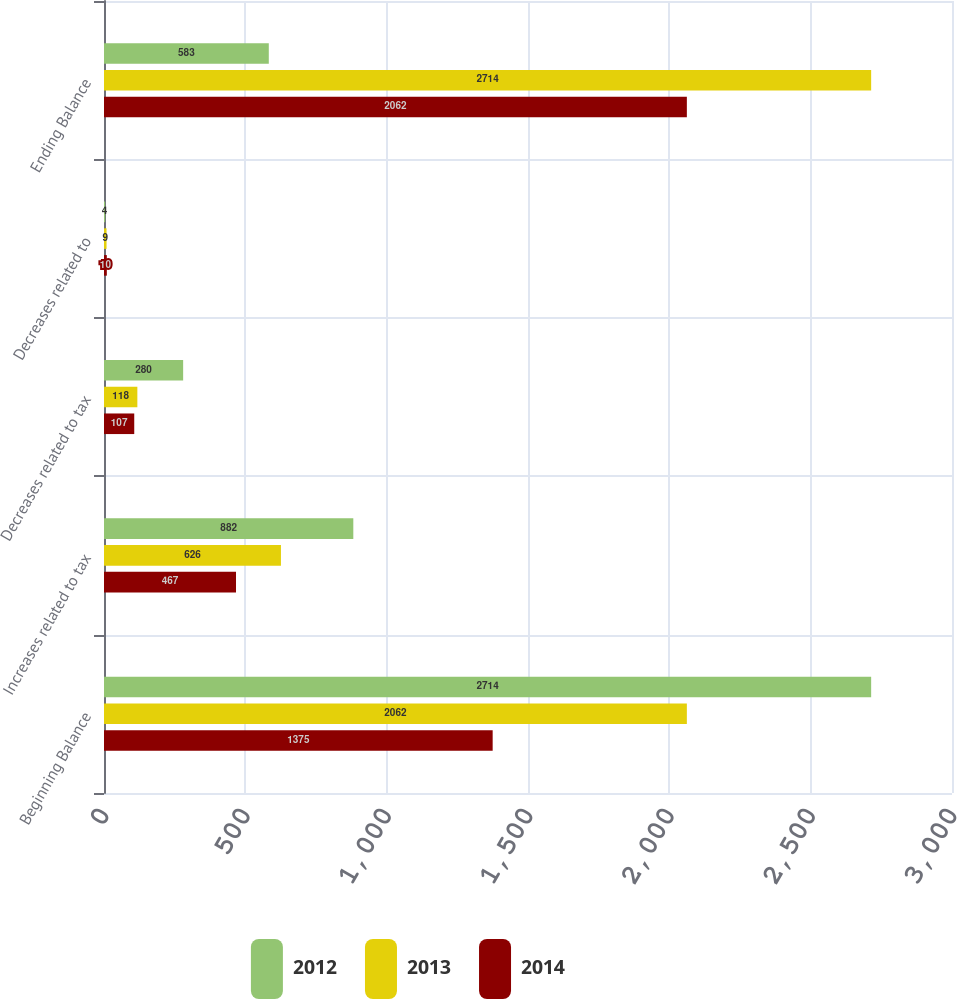Convert chart to OTSL. <chart><loc_0><loc_0><loc_500><loc_500><stacked_bar_chart><ecel><fcel>Beginning Balance<fcel>Increases related to tax<fcel>Decreases related to tax<fcel>Decreases related to<fcel>Ending Balance<nl><fcel>2012<fcel>2714<fcel>882<fcel>280<fcel>4<fcel>583<nl><fcel>2013<fcel>2062<fcel>626<fcel>118<fcel>9<fcel>2714<nl><fcel>2014<fcel>1375<fcel>467<fcel>107<fcel>10<fcel>2062<nl></chart> 